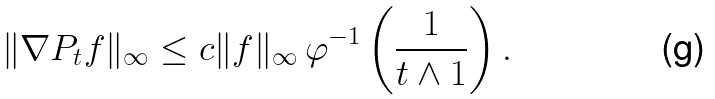Convert formula to latex. <formula><loc_0><loc_0><loc_500><loc_500>\| \nabla P _ { t } f \| _ { \infty } \leq c \| f \| _ { \infty } \, \varphi ^ { - 1 } \left ( \frac { 1 } { t \wedge 1 } \right ) .</formula> 